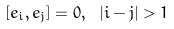Convert formula to latex. <formula><loc_0><loc_0><loc_500><loc_500>\left [ e _ { i } , e _ { j } \right ] = 0 , \ | i - j | > 1</formula> 